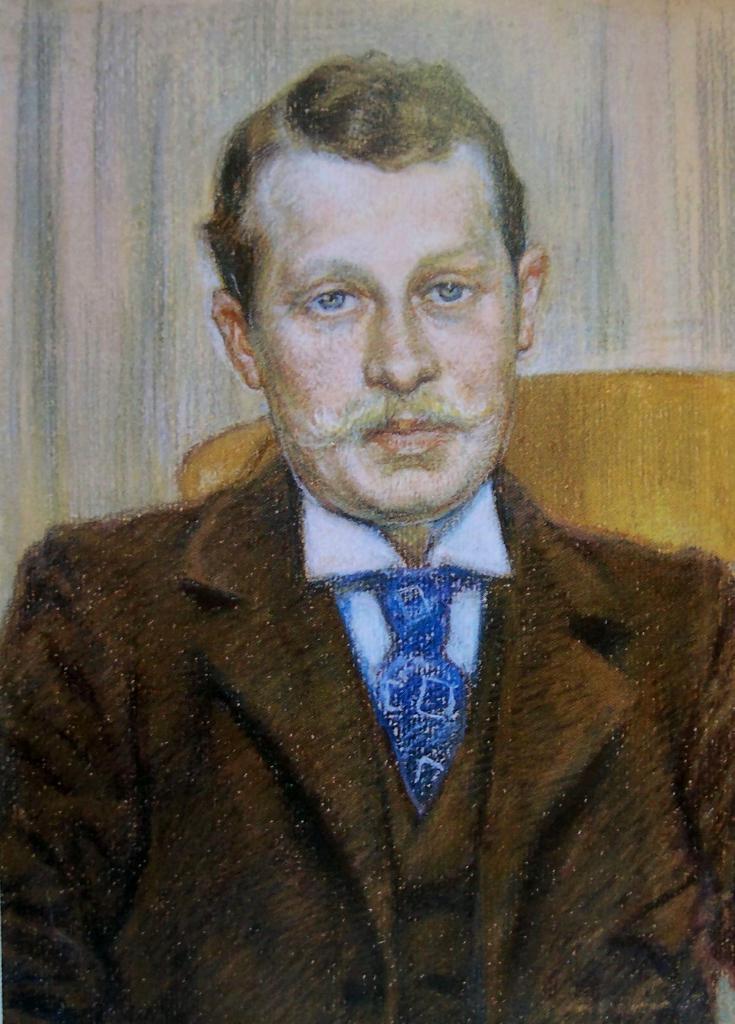Can you describe this image briefly? In this image we can see painting of a person, yellow color object, and wall. 